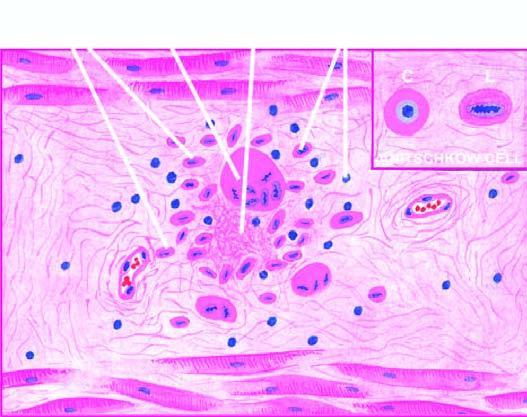what shows owl-eye appearance of central chromatin mass and perinuclear halo?
Answer the question using a single word or phrase. Cross section 